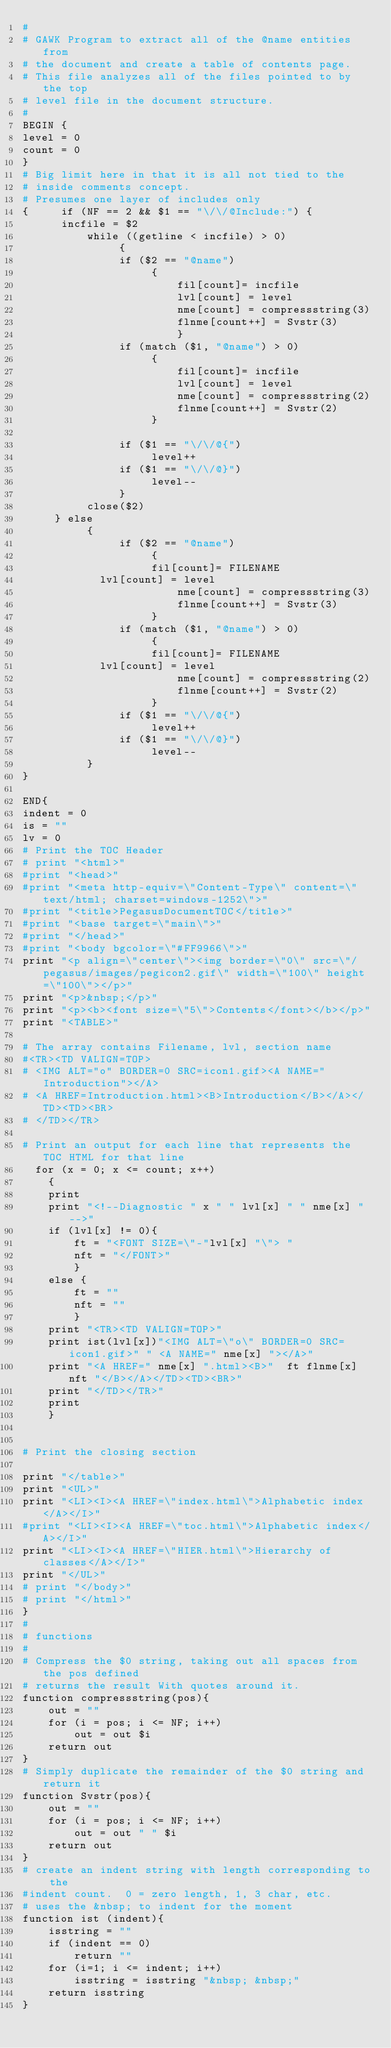<code> <loc_0><loc_0><loc_500><loc_500><_Awk_>#
# GAWK Program to extract all of the @name entities from
# the document and create a table of contents page.
# This file analyzes all of the files pointed to by the top
# level file in the document structure.
#
BEGIN {
level = 0
count = 0
}
# Big limit here in that it is all not tied to the
# inside comments concept.
# Presumes one layer of includes only
{     if (NF == 2 && $1 == "\/\/@Include:") {
	  incfile = $2
          while ((getline < incfile) > 0)
               {
               if ($2 == "@name")
               		{               			
                        fil[count]= incfile
                        lvl[count] = level
                        nme[count] = compressstring(3)
                        flnme[count++] = Svstr(3)
                        }
               if (match ($1, "@name") > 0)
               		{
                        fil[count]= incfile
                        lvl[count] = level
                        nme[count] = compressstring(2)
                        flnme[count++] = Svstr(2)
               		}
               
               if ($1 == "\/\/@{")
               		level++
               if ($1 == "\/\/@}")
               		level--
               }
          close($2)
     } else
          {
               if ($2 == "@name")
               		{
               		fil[count]= FILENAME
			lvl[count] = level
                        nme[count] = compressstring(3)
                        flnme[count++] = Svstr(3)
               		}
               if (match ($1, "@name") > 0)
               		{
               		fil[count]= FILENAME
			lvl[count] = level
                        nme[count] = compressstring(2)
                        flnme[count++] = Svstr(2)
               		}               
               if ($1 == "\/\/@{")
               		level++
               if ($1 == "\/\/@}")
               		level--
          }
}

END{
indent = 0
is = ""
lv = 0
# Print the TOC Header
# print "<html>"
#print "<head>"
#print "<meta http-equiv=\"Content-Type\" content=\"text/html; charset=windows-1252\">"
#print "<title>PegasusDocumentTOC</title>"
#print "<base target=\"main\">"
#print "</head>"
#print "<body bgcolor=\"#FF9966\">"
print "<p align=\"center\"><img border=\"0\" src=\"/pegasus/images/pegicon2.gif\" width=\"100\" height=\"100\"></p>"
print "<p>&nbsp;</p>"
print "<p><b><font size=\"5\">Contents</font></b></p>"
print "<TABLE>"

# The array contains Filename, lvl, section name
#<TR><TD VALIGN=TOP>
# <IMG ALT="o" BORDER=0 SRC=icon1.gif><A NAME="Introduction"></A>
# <A HREF=Introduction.html><B>Introduction</B></A></TD><TD><BR>
# </TD></TR>

# Print an output for each line that represents the TOC HTML for that line
  for (x = 0; x <= count; x++)
  	{
  	print
  	print "<!--Diagnostic " x " " lvl[x] " " nme[x] "-->"
  	if (lvl[x] != 0){
  		ft = "<FONT SIZE=\"-"lvl[x] "\"> "
  		nft = "</FONT>"
  		}
  	else {
  		ft = ""
  		nft = ""
  		}
  	print "<TR><TD VALIGN=TOP>"
  	print ist(lvl[x])"<IMG ALT=\"o\" BORDER=0 SRC=icon1.gif>" " <A NAME=" nme[x] "></A>"
  	print "<A HREF=" nme[x] ".html><B>"  ft flnme[x] nft "</B></A></TD><TD><BR>"
  	print "</TD></TR>"
  	print	
  	}
   

# Print the closing section

print "</table>"
print "<UL>"
print "<LI><I><A HREF=\"index.html\">Alphabetic index</A></I>"
#print "<LI><I><A HREF=\"toc.html\">Alphabetic index</A></I>"
print "<LI><I><A HREF=\"HIER.html\">Hierarchy of classes</A></I>"
print "</UL>"
# print "</body>"
# print "</html>"
}
#
# functions
#
# Compress the $0 string, taking out all spaces from the pos defined
# returns the result With quotes around it.
function compressstring(pos){ 
	out = ""
	for (i = pos; i <= NF; i++)
		out = out $i
	return out
}
# Simply duplicate the remainder of the $0 string and return it
function Svstr(pos){
	out = ""
	for (i = pos; i <= NF; i++)
		out = out " " $i
	return out
}
# create an indent string with length corresponding to the
#indent count.  0 = zero length, 1, 3 char, etc.
# uses the &nbsp; to indent for the moment
function ist (indent){
	isstring = ""
	if (indent == 0)
		return ""
	for (i=1; i <= indent; i++)
		isstring = isstring "&nbsp; &nbsp;"
	return isstring
}</code> 